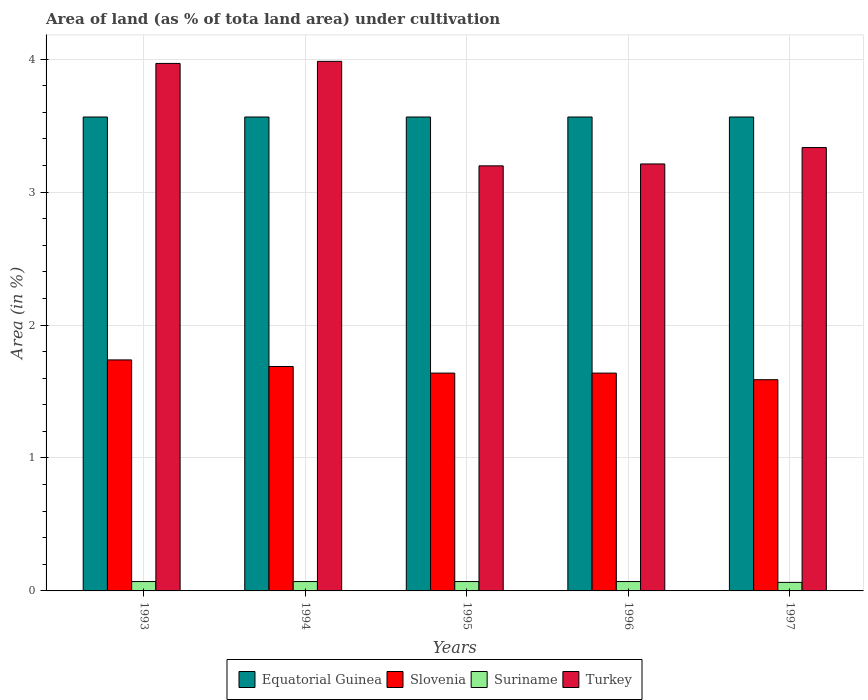How many groups of bars are there?
Provide a succinct answer. 5. Are the number of bars per tick equal to the number of legend labels?
Offer a terse response. Yes. How many bars are there on the 4th tick from the left?
Keep it short and to the point. 4. How many bars are there on the 1st tick from the right?
Keep it short and to the point. 4. What is the label of the 1st group of bars from the left?
Ensure brevity in your answer.  1993. What is the percentage of land under cultivation in Suriname in 1996?
Ensure brevity in your answer.  0.07. Across all years, what is the maximum percentage of land under cultivation in Slovenia?
Your response must be concise. 1.74. Across all years, what is the minimum percentage of land under cultivation in Suriname?
Give a very brief answer. 0.06. In which year was the percentage of land under cultivation in Suriname maximum?
Offer a very short reply. 1993. What is the total percentage of land under cultivation in Equatorial Guinea in the graph?
Your response must be concise. 17.83. What is the difference between the percentage of land under cultivation in Equatorial Guinea in 1993 and the percentage of land under cultivation in Suriname in 1995?
Provide a short and direct response. 3.49. What is the average percentage of land under cultivation in Suriname per year?
Make the answer very short. 0.07. In the year 1996, what is the difference between the percentage of land under cultivation in Turkey and percentage of land under cultivation in Suriname?
Offer a very short reply. 3.14. In how many years, is the percentage of land under cultivation in Equatorial Guinea greater than 1.6 %?
Your answer should be compact. 5. What is the ratio of the percentage of land under cultivation in Slovenia in 1995 to that in 1997?
Provide a short and direct response. 1.03. Is the difference between the percentage of land under cultivation in Turkey in 1993 and 1995 greater than the difference between the percentage of land under cultivation in Suriname in 1993 and 1995?
Offer a terse response. Yes. Is the sum of the percentage of land under cultivation in Suriname in 1993 and 1997 greater than the maximum percentage of land under cultivation in Equatorial Guinea across all years?
Offer a terse response. No. Is it the case that in every year, the sum of the percentage of land under cultivation in Slovenia and percentage of land under cultivation in Suriname is greater than the sum of percentage of land under cultivation in Turkey and percentage of land under cultivation in Equatorial Guinea?
Your response must be concise. Yes. What does the 2nd bar from the left in 1997 represents?
Give a very brief answer. Slovenia. What does the 3rd bar from the right in 1994 represents?
Offer a terse response. Slovenia. Is it the case that in every year, the sum of the percentage of land under cultivation in Suriname and percentage of land under cultivation in Turkey is greater than the percentage of land under cultivation in Slovenia?
Offer a very short reply. Yes. Are the values on the major ticks of Y-axis written in scientific E-notation?
Your answer should be very brief. No. Does the graph contain grids?
Keep it short and to the point. Yes. Where does the legend appear in the graph?
Provide a short and direct response. Bottom center. How many legend labels are there?
Keep it short and to the point. 4. What is the title of the graph?
Your answer should be very brief. Area of land (as % of tota land area) under cultivation. What is the label or title of the Y-axis?
Provide a succinct answer. Area (in %). What is the Area (in %) of Equatorial Guinea in 1993?
Give a very brief answer. 3.57. What is the Area (in %) of Slovenia in 1993?
Offer a very short reply. 1.74. What is the Area (in %) of Suriname in 1993?
Your response must be concise. 0.07. What is the Area (in %) in Turkey in 1993?
Offer a very short reply. 3.97. What is the Area (in %) of Equatorial Guinea in 1994?
Ensure brevity in your answer.  3.57. What is the Area (in %) of Slovenia in 1994?
Your answer should be very brief. 1.69. What is the Area (in %) of Suriname in 1994?
Your response must be concise. 0.07. What is the Area (in %) in Turkey in 1994?
Give a very brief answer. 3.98. What is the Area (in %) of Equatorial Guinea in 1995?
Make the answer very short. 3.57. What is the Area (in %) of Slovenia in 1995?
Provide a short and direct response. 1.64. What is the Area (in %) of Suriname in 1995?
Ensure brevity in your answer.  0.07. What is the Area (in %) in Turkey in 1995?
Offer a terse response. 3.2. What is the Area (in %) in Equatorial Guinea in 1996?
Provide a succinct answer. 3.57. What is the Area (in %) of Slovenia in 1996?
Your answer should be compact. 1.64. What is the Area (in %) of Suriname in 1996?
Your response must be concise. 0.07. What is the Area (in %) in Turkey in 1996?
Make the answer very short. 3.21. What is the Area (in %) in Equatorial Guinea in 1997?
Provide a succinct answer. 3.57. What is the Area (in %) of Slovenia in 1997?
Provide a succinct answer. 1.59. What is the Area (in %) in Suriname in 1997?
Offer a terse response. 0.06. What is the Area (in %) in Turkey in 1997?
Your answer should be very brief. 3.34. Across all years, what is the maximum Area (in %) of Equatorial Guinea?
Your answer should be very brief. 3.57. Across all years, what is the maximum Area (in %) of Slovenia?
Make the answer very short. 1.74. Across all years, what is the maximum Area (in %) in Suriname?
Give a very brief answer. 0.07. Across all years, what is the maximum Area (in %) of Turkey?
Provide a succinct answer. 3.98. Across all years, what is the minimum Area (in %) of Equatorial Guinea?
Your response must be concise. 3.57. Across all years, what is the minimum Area (in %) in Slovenia?
Offer a terse response. 1.59. Across all years, what is the minimum Area (in %) in Suriname?
Ensure brevity in your answer.  0.06. Across all years, what is the minimum Area (in %) of Turkey?
Provide a short and direct response. 3.2. What is the total Area (in %) in Equatorial Guinea in the graph?
Give a very brief answer. 17.83. What is the total Area (in %) of Slovenia in the graph?
Offer a terse response. 8.29. What is the total Area (in %) of Suriname in the graph?
Your response must be concise. 0.35. What is the total Area (in %) of Turkey in the graph?
Provide a short and direct response. 17.7. What is the difference between the Area (in %) in Equatorial Guinea in 1993 and that in 1994?
Make the answer very short. 0. What is the difference between the Area (in %) of Slovenia in 1993 and that in 1994?
Your answer should be very brief. 0.05. What is the difference between the Area (in %) of Suriname in 1993 and that in 1994?
Offer a very short reply. 0. What is the difference between the Area (in %) of Turkey in 1993 and that in 1994?
Offer a very short reply. -0.02. What is the difference between the Area (in %) of Equatorial Guinea in 1993 and that in 1995?
Your answer should be very brief. 0. What is the difference between the Area (in %) in Slovenia in 1993 and that in 1995?
Make the answer very short. 0.1. What is the difference between the Area (in %) of Suriname in 1993 and that in 1995?
Your answer should be very brief. 0. What is the difference between the Area (in %) in Turkey in 1993 and that in 1995?
Keep it short and to the point. 0.77. What is the difference between the Area (in %) in Equatorial Guinea in 1993 and that in 1996?
Provide a short and direct response. 0. What is the difference between the Area (in %) of Slovenia in 1993 and that in 1996?
Give a very brief answer. 0.1. What is the difference between the Area (in %) in Turkey in 1993 and that in 1996?
Your answer should be compact. 0.76. What is the difference between the Area (in %) of Equatorial Guinea in 1993 and that in 1997?
Make the answer very short. 0. What is the difference between the Area (in %) in Slovenia in 1993 and that in 1997?
Keep it short and to the point. 0.15. What is the difference between the Area (in %) in Suriname in 1993 and that in 1997?
Offer a very short reply. 0.01. What is the difference between the Area (in %) of Turkey in 1993 and that in 1997?
Your response must be concise. 0.63. What is the difference between the Area (in %) of Equatorial Guinea in 1994 and that in 1995?
Keep it short and to the point. 0. What is the difference between the Area (in %) of Slovenia in 1994 and that in 1995?
Provide a succinct answer. 0.05. What is the difference between the Area (in %) in Turkey in 1994 and that in 1995?
Offer a terse response. 0.79. What is the difference between the Area (in %) in Slovenia in 1994 and that in 1996?
Make the answer very short. 0.05. What is the difference between the Area (in %) of Suriname in 1994 and that in 1996?
Offer a very short reply. 0. What is the difference between the Area (in %) in Turkey in 1994 and that in 1996?
Offer a terse response. 0.77. What is the difference between the Area (in %) of Slovenia in 1994 and that in 1997?
Your answer should be very brief. 0.1. What is the difference between the Area (in %) of Suriname in 1994 and that in 1997?
Offer a terse response. 0.01. What is the difference between the Area (in %) in Turkey in 1994 and that in 1997?
Your answer should be compact. 0.65. What is the difference between the Area (in %) in Slovenia in 1995 and that in 1996?
Give a very brief answer. 0. What is the difference between the Area (in %) in Turkey in 1995 and that in 1996?
Provide a succinct answer. -0.01. What is the difference between the Area (in %) of Slovenia in 1995 and that in 1997?
Provide a succinct answer. 0.05. What is the difference between the Area (in %) in Suriname in 1995 and that in 1997?
Your answer should be very brief. 0.01. What is the difference between the Area (in %) of Turkey in 1995 and that in 1997?
Make the answer very short. -0.14. What is the difference between the Area (in %) in Equatorial Guinea in 1996 and that in 1997?
Make the answer very short. 0. What is the difference between the Area (in %) in Slovenia in 1996 and that in 1997?
Offer a very short reply. 0.05. What is the difference between the Area (in %) in Suriname in 1996 and that in 1997?
Provide a succinct answer. 0.01. What is the difference between the Area (in %) in Turkey in 1996 and that in 1997?
Your response must be concise. -0.12. What is the difference between the Area (in %) in Equatorial Guinea in 1993 and the Area (in %) in Slovenia in 1994?
Provide a short and direct response. 1.88. What is the difference between the Area (in %) in Equatorial Guinea in 1993 and the Area (in %) in Suriname in 1994?
Your answer should be compact. 3.49. What is the difference between the Area (in %) in Equatorial Guinea in 1993 and the Area (in %) in Turkey in 1994?
Keep it short and to the point. -0.42. What is the difference between the Area (in %) of Slovenia in 1993 and the Area (in %) of Suriname in 1994?
Offer a terse response. 1.67. What is the difference between the Area (in %) of Slovenia in 1993 and the Area (in %) of Turkey in 1994?
Provide a short and direct response. -2.25. What is the difference between the Area (in %) in Suriname in 1993 and the Area (in %) in Turkey in 1994?
Provide a short and direct response. -3.91. What is the difference between the Area (in %) of Equatorial Guinea in 1993 and the Area (in %) of Slovenia in 1995?
Provide a succinct answer. 1.93. What is the difference between the Area (in %) in Equatorial Guinea in 1993 and the Area (in %) in Suriname in 1995?
Make the answer very short. 3.49. What is the difference between the Area (in %) of Equatorial Guinea in 1993 and the Area (in %) of Turkey in 1995?
Keep it short and to the point. 0.37. What is the difference between the Area (in %) in Slovenia in 1993 and the Area (in %) in Suriname in 1995?
Your answer should be very brief. 1.67. What is the difference between the Area (in %) in Slovenia in 1993 and the Area (in %) in Turkey in 1995?
Offer a very short reply. -1.46. What is the difference between the Area (in %) in Suriname in 1993 and the Area (in %) in Turkey in 1995?
Your response must be concise. -3.13. What is the difference between the Area (in %) of Equatorial Guinea in 1993 and the Area (in %) of Slovenia in 1996?
Ensure brevity in your answer.  1.93. What is the difference between the Area (in %) of Equatorial Guinea in 1993 and the Area (in %) of Suriname in 1996?
Your response must be concise. 3.49. What is the difference between the Area (in %) in Equatorial Guinea in 1993 and the Area (in %) in Turkey in 1996?
Give a very brief answer. 0.35. What is the difference between the Area (in %) in Slovenia in 1993 and the Area (in %) in Suriname in 1996?
Your answer should be very brief. 1.67. What is the difference between the Area (in %) of Slovenia in 1993 and the Area (in %) of Turkey in 1996?
Your response must be concise. -1.47. What is the difference between the Area (in %) in Suriname in 1993 and the Area (in %) in Turkey in 1996?
Offer a terse response. -3.14. What is the difference between the Area (in %) in Equatorial Guinea in 1993 and the Area (in %) in Slovenia in 1997?
Your answer should be compact. 1.98. What is the difference between the Area (in %) of Equatorial Guinea in 1993 and the Area (in %) of Suriname in 1997?
Your answer should be very brief. 3.5. What is the difference between the Area (in %) of Equatorial Guinea in 1993 and the Area (in %) of Turkey in 1997?
Keep it short and to the point. 0.23. What is the difference between the Area (in %) of Slovenia in 1993 and the Area (in %) of Suriname in 1997?
Your answer should be very brief. 1.67. What is the difference between the Area (in %) of Slovenia in 1993 and the Area (in %) of Turkey in 1997?
Offer a terse response. -1.6. What is the difference between the Area (in %) of Suriname in 1993 and the Area (in %) of Turkey in 1997?
Ensure brevity in your answer.  -3.26. What is the difference between the Area (in %) in Equatorial Guinea in 1994 and the Area (in %) in Slovenia in 1995?
Your response must be concise. 1.93. What is the difference between the Area (in %) of Equatorial Guinea in 1994 and the Area (in %) of Suriname in 1995?
Provide a short and direct response. 3.49. What is the difference between the Area (in %) in Equatorial Guinea in 1994 and the Area (in %) in Turkey in 1995?
Make the answer very short. 0.37. What is the difference between the Area (in %) of Slovenia in 1994 and the Area (in %) of Suriname in 1995?
Provide a succinct answer. 1.62. What is the difference between the Area (in %) of Slovenia in 1994 and the Area (in %) of Turkey in 1995?
Ensure brevity in your answer.  -1.51. What is the difference between the Area (in %) of Suriname in 1994 and the Area (in %) of Turkey in 1995?
Provide a succinct answer. -3.13. What is the difference between the Area (in %) of Equatorial Guinea in 1994 and the Area (in %) of Slovenia in 1996?
Make the answer very short. 1.93. What is the difference between the Area (in %) in Equatorial Guinea in 1994 and the Area (in %) in Suriname in 1996?
Your answer should be very brief. 3.49. What is the difference between the Area (in %) in Equatorial Guinea in 1994 and the Area (in %) in Turkey in 1996?
Make the answer very short. 0.35. What is the difference between the Area (in %) in Slovenia in 1994 and the Area (in %) in Suriname in 1996?
Provide a succinct answer. 1.62. What is the difference between the Area (in %) of Slovenia in 1994 and the Area (in %) of Turkey in 1996?
Keep it short and to the point. -1.52. What is the difference between the Area (in %) of Suriname in 1994 and the Area (in %) of Turkey in 1996?
Make the answer very short. -3.14. What is the difference between the Area (in %) in Equatorial Guinea in 1994 and the Area (in %) in Slovenia in 1997?
Offer a terse response. 1.98. What is the difference between the Area (in %) of Equatorial Guinea in 1994 and the Area (in %) of Suriname in 1997?
Give a very brief answer. 3.5. What is the difference between the Area (in %) of Equatorial Guinea in 1994 and the Area (in %) of Turkey in 1997?
Offer a terse response. 0.23. What is the difference between the Area (in %) of Slovenia in 1994 and the Area (in %) of Suriname in 1997?
Offer a very short reply. 1.62. What is the difference between the Area (in %) of Slovenia in 1994 and the Area (in %) of Turkey in 1997?
Make the answer very short. -1.65. What is the difference between the Area (in %) in Suriname in 1994 and the Area (in %) in Turkey in 1997?
Offer a terse response. -3.26. What is the difference between the Area (in %) in Equatorial Guinea in 1995 and the Area (in %) in Slovenia in 1996?
Offer a terse response. 1.93. What is the difference between the Area (in %) in Equatorial Guinea in 1995 and the Area (in %) in Suriname in 1996?
Offer a terse response. 3.49. What is the difference between the Area (in %) in Equatorial Guinea in 1995 and the Area (in %) in Turkey in 1996?
Provide a short and direct response. 0.35. What is the difference between the Area (in %) in Slovenia in 1995 and the Area (in %) in Suriname in 1996?
Your response must be concise. 1.57. What is the difference between the Area (in %) of Slovenia in 1995 and the Area (in %) of Turkey in 1996?
Provide a succinct answer. -1.57. What is the difference between the Area (in %) in Suriname in 1995 and the Area (in %) in Turkey in 1996?
Offer a very short reply. -3.14. What is the difference between the Area (in %) in Equatorial Guinea in 1995 and the Area (in %) in Slovenia in 1997?
Your answer should be very brief. 1.98. What is the difference between the Area (in %) in Equatorial Guinea in 1995 and the Area (in %) in Suriname in 1997?
Offer a very short reply. 3.5. What is the difference between the Area (in %) of Equatorial Guinea in 1995 and the Area (in %) of Turkey in 1997?
Your answer should be compact. 0.23. What is the difference between the Area (in %) of Slovenia in 1995 and the Area (in %) of Suriname in 1997?
Your answer should be compact. 1.57. What is the difference between the Area (in %) of Slovenia in 1995 and the Area (in %) of Turkey in 1997?
Your answer should be very brief. -1.7. What is the difference between the Area (in %) of Suriname in 1995 and the Area (in %) of Turkey in 1997?
Offer a very short reply. -3.26. What is the difference between the Area (in %) in Equatorial Guinea in 1996 and the Area (in %) in Slovenia in 1997?
Offer a very short reply. 1.98. What is the difference between the Area (in %) of Equatorial Guinea in 1996 and the Area (in %) of Suriname in 1997?
Your answer should be compact. 3.5. What is the difference between the Area (in %) of Equatorial Guinea in 1996 and the Area (in %) of Turkey in 1997?
Provide a succinct answer. 0.23. What is the difference between the Area (in %) of Slovenia in 1996 and the Area (in %) of Suriname in 1997?
Ensure brevity in your answer.  1.57. What is the difference between the Area (in %) of Slovenia in 1996 and the Area (in %) of Turkey in 1997?
Your response must be concise. -1.7. What is the difference between the Area (in %) in Suriname in 1996 and the Area (in %) in Turkey in 1997?
Ensure brevity in your answer.  -3.26. What is the average Area (in %) of Equatorial Guinea per year?
Keep it short and to the point. 3.57. What is the average Area (in %) in Slovenia per year?
Make the answer very short. 1.66. What is the average Area (in %) in Suriname per year?
Provide a short and direct response. 0.07. What is the average Area (in %) in Turkey per year?
Offer a terse response. 3.54. In the year 1993, what is the difference between the Area (in %) of Equatorial Guinea and Area (in %) of Slovenia?
Make the answer very short. 1.83. In the year 1993, what is the difference between the Area (in %) of Equatorial Guinea and Area (in %) of Suriname?
Provide a short and direct response. 3.49. In the year 1993, what is the difference between the Area (in %) in Equatorial Guinea and Area (in %) in Turkey?
Offer a very short reply. -0.4. In the year 1993, what is the difference between the Area (in %) of Slovenia and Area (in %) of Suriname?
Give a very brief answer. 1.67. In the year 1993, what is the difference between the Area (in %) in Slovenia and Area (in %) in Turkey?
Your response must be concise. -2.23. In the year 1993, what is the difference between the Area (in %) of Suriname and Area (in %) of Turkey?
Offer a terse response. -3.9. In the year 1994, what is the difference between the Area (in %) of Equatorial Guinea and Area (in %) of Slovenia?
Give a very brief answer. 1.88. In the year 1994, what is the difference between the Area (in %) of Equatorial Guinea and Area (in %) of Suriname?
Keep it short and to the point. 3.49. In the year 1994, what is the difference between the Area (in %) of Equatorial Guinea and Area (in %) of Turkey?
Provide a short and direct response. -0.42. In the year 1994, what is the difference between the Area (in %) in Slovenia and Area (in %) in Suriname?
Your answer should be compact. 1.62. In the year 1994, what is the difference between the Area (in %) of Slovenia and Area (in %) of Turkey?
Your answer should be very brief. -2.3. In the year 1994, what is the difference between the Area (in %) of Suriname and Area (in %) of Turkey?
Keep it short and to the point. -3.91. In the year 1995, what is the difference between the Area (in %) in Equatorial Guinea and Area (in %) in Slovenia?
Provide a short and direct response. 1.93. In the year 1995, what is the difference between the Area (in %) of Equatorial Guinea and Area (in %) of Suriname?
Offer a very short reply. 3.49. In the year 1995, what is the difference between the Area (in %) in Equatorial Guinea and Area (in %) in Turkey?
Ensure brevity in your answer.  0.37. In the year 1995, what is the difference between the Area (in %) of Slovenia and Area (in %) of Suriname?
Your response must be concise. 1.57. In the year 1995, what is the difference between the Area (in %) in Slovenia and Area (in %) in Turkey?
Your answer should be compact. -1.56. In the year 1995, what is the difference between the Area (in %) in Suriname and Area (in %) in Turkey?
Make the answer very short. -3.13. In the year 1996, what is the difference between the Area (in %) in Equatorial Guinea and Area (in %) in Slovenia?
Give a very brief answer. 1.93. In the year 1996, what is the difference between the Area (in %) of Equatorial Guinea and Area (in %) of Suriname?
Your answer should be very brief. 3.49. In the year 1996, what is the difference between the Area (in %) of Equatorial Guinea and Area (in %) of Turkey?
Your response must be concise. 0.35. In the year 1996, what is the difference between the Area (in %) in Slovenia and Area (in %) in Suriname?
Offer a very short reply. 1.57. In the year 1996, what is the difference between the Area (in %) in Slovenia and Area (in %) in Turkey?
Make the answer very short. -1.57. In the year 1996, what is the difference between the Area (in %) of Suriname and Area (in %) of Turkey?
Keep it short and to the point. -3.14. In the year 1997, what is the difference between the Area (in %) of Equatorial Guinea and Area (in %) of Slovenia?
Your response must be concise. 1.98. In the year 1997, what is the difference between the Area (in %) in Equatorial Guinea and Area (in %) in Suriname?
Give a very brief answer. 3.5. In the year 1997, what is the difference between the Area (in %) of Equatorial Guinea and Area (in %) of Turkey?
Make the answer very short. 0.23. In the year 1997, what is the difference between the Area (in %) in Slovenia and Area (in %) in Suriname?
Your answer should be very brief. 1.52. In the year 1997, what is the difference between the Area (in %) of Slovenia and Area (in %) of Turkey?
Give a very brief answer. -1.75. In the year 1997, what is the difference between the Area (in %) of Suriname and Area (in %) of Turkey?
Provide a succinct answer. -3.27. What is the ratio of the Area (in %) in Slovenia in 1993 to that in 1994?
Your answer should be very brief. 1.03. What is the ratio of the Area (in %) in Turkey in 1993 to that in 1994?
Provide a succinct answer. 1. What is the ratio of the Area (in %) in Equatorial Guinea in 1993 to that in 1995?
Provide a succinct answer. 1. What is the ratio of the Area (in %) in Slovenia in 1993 to that in 1995?
Ensure brevity in your answer.  1.06. What is the ratio of the Area (in %) in Suriname in 1993 to that in 1995?
Keep it short and to the point. 1. What is the ratio of the Area (in %) in Turkey in 1993 to that in 1995?
Provide a short and direct response. 1.24. What is the ratio of the Area (in %) in Slovenia in 1993 to that in 1996?
Provide a succinct answer. 1.06. What is the ratio of the Area (in %) in Turkey in 1993 to that in 1996?
Offer a terse response. 1.24. What is the ratio of the Area (in %) in Slovenia in 1993 to that in 1997?
Your answer should be very brief. 1.09. What is the ratio of the Area (in %) of Suriname in 1993 to that in 1997?
Your answer should be compact. 1.1. What is the ratio of the Area (in %) in Turkey in 1993 to that in 1997?
Ensure brevity in your answer.  1.19. What is the ratio of the Area (in %) in Slovenia in 1994 to that in 1995?
Make the answer very short. 1.03. What is the ratio of the Area (in %) of Suriname in 1994 to that in 1995?
Keep it short and to the point. 1. What is the ratio of the Area (in %) in Turkey in 1994 to that in 1995?
Your response must be concise. 1.25. What is the ratio of the Area (in %) in Equatorial Guinea in 1994 to that in 1996?
Your answer should be compact. 1. What is the ratio of the Area (in %) of Slovenia in 1994 to that in 1996?
Keep it short and to the point. 1.03. What is the ratio of the Area (in %) of Suriname in 1994 to that in 1996?
Your answer should be compact. 1. What is the ratio of the Area (in %) in Turkey in 1994 to that in 1996?
Provide a succinct answer. 1.24. What is the ratio of the Area (in %) of Slovenia in 1994 to that in 1997?
Make the answer very short. 1.06. What is the ratio of the Area (in %) of Turkey in 1994 to that in 1997?
Keep it short and to the point. 1.19. What is the ratio of the Area (in %) in Equatorial Guinea in 1995 to that in 1996?
Provide a succinct answer. 1. What is the ratio of the Area (in %) in Slovenia in 1995 to that in 1996?
Make the answer very short. 1. What is the ratio of the Area (in %) of Suriname in 1995 to that in 1996?
Provide a succinct answer. 1. What is the ratio of the Area (in %) in Equatorial Guinea in 1995 to that in 1997?
Provide a succinct answer. 1. What is the ratio of the Area (in %) in Slovenia in 1995 to that in 1997?
Ensure brevity in your answer.  1.03. What is the ratio of the Area (in %) in Suriname in 1995 to that in 1997?
Provide a short and direct response. 1.1. What is the ratio of the Area (in %) in Turkey in 1995 to that in 1997?
Give a very brief answer. 0.96. What is the ratio of the Area (in %) in Equatorial Guinea in 1996 to that in 1997?
Your answer should be compact. 1. What is the ratio of the Area (in %) of Slovenia in 1996 to that in 1997?
Keep it short and to the point. 1.03. What is the ratio of the Area (in %) of Suriname in 1996 to that in 1997?
Provide a short and direct response. 1.1. What is the difference between the highest and the second highest Area (in %) in Equatorial Guinea?
Give a very brief answer. 0. What is the difference between the highest and the second highest Area (in %) in Slovenia?
Make the answer very short. 0.05. What is the difference between the highest and the second highest Area (in %) in Suriname?
Your response must be concise. 0. What is the difference between the highest and the second highest Area (in %) of Turkey?
Keep it short and to the point. 0.02. What is the difference between the highest and the lowest Area (in %) in Equatorial Guinea?
Offer a very short reply. 0. What is the difference between the highest and the lowest Area (in %) in Slovenia?
Keep it short and to the point. 0.15. What is the difference between the highest and the lowest Area (in %) of Suriname?
Keep it short and to the point. 0.01. What is the difference between the highest and the lowest Area (in %) in Turkey?
Your answer should be compact. 0.79. 